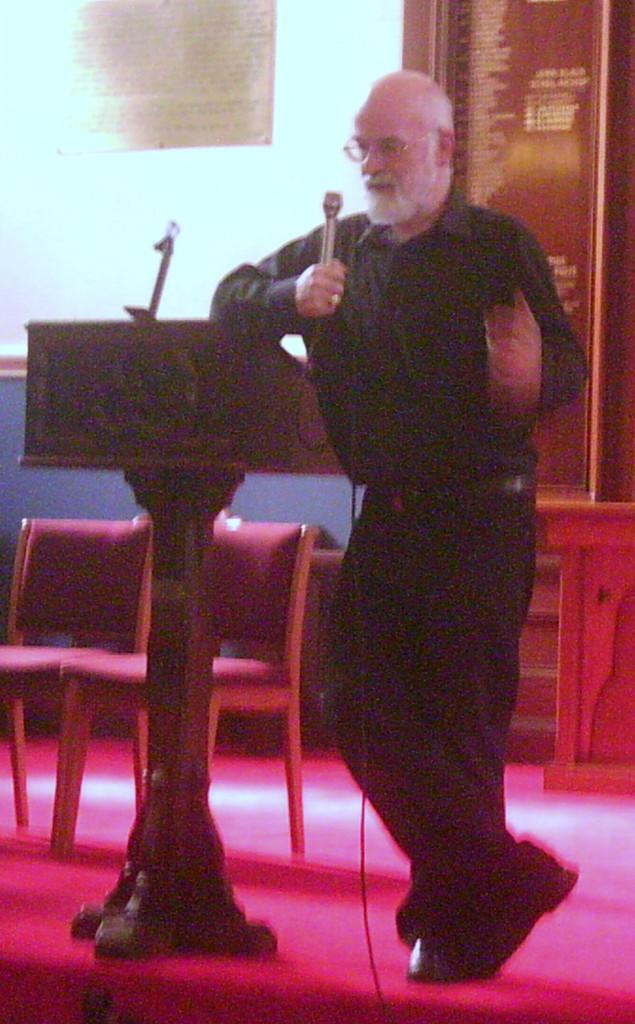What is the man in the image doing? The man is standing in the image and holding a microphone. Where is the man located in relation to the podium? The man is beside a podium in the image. What else can be seen on the stage in the image? There are chairs on the stage in the image. What theory does the man's aunt propose in the image? There is no mention of an aunt or any theory in the image; it simply shows a man holding a microphone and standing beside a podium. 